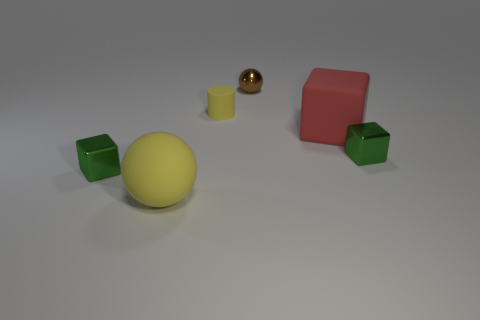Subtract all metallic blocks. How many blocks are left? 1 Add 3 green shiny blocks. How many objects exist? 9 Subtract all cylinders. How many objects are left? 5 Subtract 0 blue cylinders. How many objects are left? 6 Subtract all green things. Subtract all yellow cylinders. How many objects are left? 3 Add 5 small metal balls. How many small metal balls are left? 6 Add 4 yellow cylinders. How many yellow cylinders exist? 5 